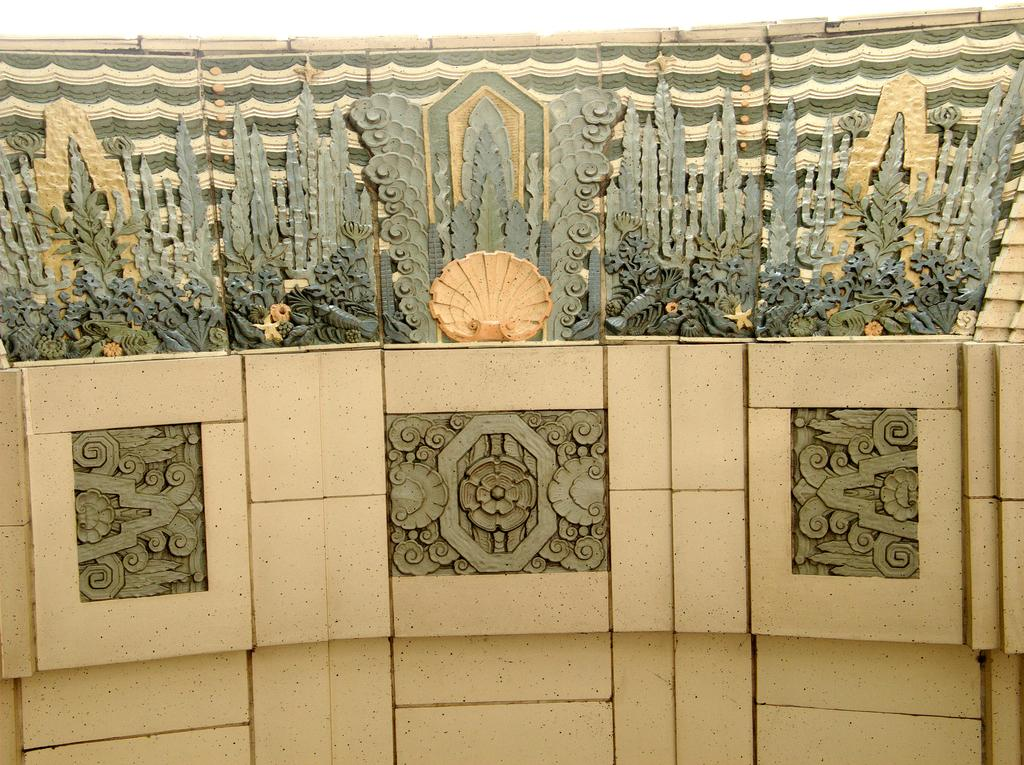What type of material covers the wall in the image? There are tiles attached to the wall in the image. Are all the tiles the same or do they have variations? Some of the tiles are plain, while others have different designs. What type of toothpaste is used to clean the tiles in the image? There is no toothpaste present in the image, as it is a wall covered with tiles. How many pigs can be seen interacting with the tiles in the image? There are no pigs present in the image; it only features tiles on a wall. 